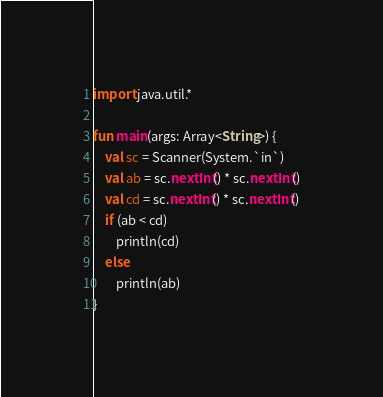<code> <loc_0><loc_0><loc_500><loc_500><_Kotlin_>import java.util.*

fun main(args: Array<String>) {
    val sc = Scanner(System.`in`)
    val ab = sc.nextInt() * sc.nextInt()
    val cd = sc.nextInt() * sc.nextInt()
    if (ab < cd)
        println(cd)
    else 
        println(ab)
}</code> 